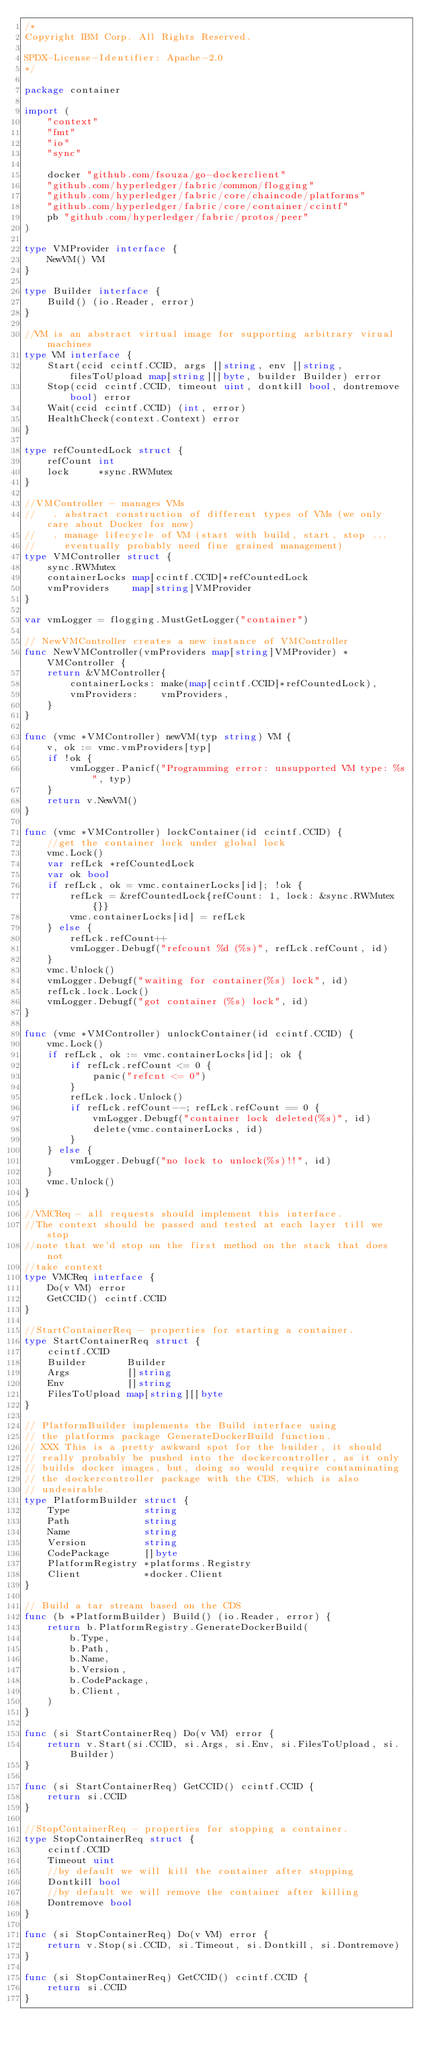Convert code to text. <code><loc_0><loc_0><loc_500><loc_500><_Go_>/*
Copyright IBM Corp. All Rights Reserved.

SPDX-License-Identifier: Apache-2.0
*/

package container

import (
	"context"
	"fmt"
	"io"
	"sync"

	docker "github.com/fsouza/go-dockerclient"
	"github.com/hyperledger/fabric/common/flogging"
	"github.com/hyperledger/fabric/core/chaincode/platforms"
	"github.com/hyperledger/fabric/core/container/ccintf"
	pb "github.com/hyperledger/fabric/protos/peer"
)

type VMProvider interface {
	NewVM() VM
}

type Builder interface {
	Build() (io.Reader, error)
}

//VM is an abstract virtual image for supporting arbitrary virual machines
type VM interface {
	Start(ccid ccintf.CCID, args []string, env []string, filesToUpload map[string][]byte, builder Builder) error
	Stop(ccid ccintf.CCID, timeout uint, dontkill bool, dontremove bool) error
	Wait(ccid ccintf.CCID) (int, error)
	HealthCheck(context.Context) error
}

type refCountedLock struct {
	refCount int
	lock     *sync.RWMutex
}

//VMController - manages VMs
//   . abstract construction of different types of VMs (we only care about Docker for now)
//   . manage lifecycle of VM (start with build, start, stop ...
//     eventually probably need fine grained management)
type VMController struct {
	sync.RWMutex
	containerLocks map[ccintf.CCID]*refCountedLock
	vmProviders    map[string]VMProvider
}

var vmLogger = flogging.MustGetLogger("container")

// NewVMController creates a new instance of VMController
func NewVMController(vmProviders map[string]VMProvider) *VMController {
	return &VMController{
		containerLocks: make(map[ccintf.CCID]*refCountedLock),
		vmProviders:    vmProviders,
	}
}

func (vmc *VMController) newVM(typ string) VM {
	v, ok := vmc.vmProviders[typ]
	if !ok {
		vmLogger.Panicf("Programming error: unsupported VM type: %s", typ)
	}
	return v.NewVM()
}

func (vmc *VMController) lockContainer(id ccintf.CCID) {
	//get the container lock under global lock
	vmc.Lock()
	var refLck *refCountedLock
	var ok bool
	if refLck, ok = vmc.containerLocks[id]; !ok {
		refLck = &refCountedLock{refCount: 1, lock: &sync.RWMutex{}}
		vmc.containerLocks[id] = refLck
	} else {
		refLck.refCount++
		vmLogger.Debugf("refcount %d (%s)", refLck.refCount, id)
	}
	vmc.Unlock()
	vmLogger.Debugf("waiting for container(%s) lock", id)
	refLck.lock.Lock()
	vmLogger.Debugf("got container (%s) lock", id)
}

func (vmc *VMController) unlockContainer(id ccintf.CCID) {
	vmc.Lock()
	if refLck, ok := vmc.containerLocks[id]; ok {
		if refLck.refCount <= 0 {
			panic("refcnt <= 0")
		}
		refLck.lock.Unlock()
		if refLck.refCount--; refLck.refCount == 0 {
			vmLogger.Debugf("container lock deleted(%s)", id)
			delete(vmc.containerLocks, id)
		}
	} else {
		vmLogger.Debugf("no lock to unlock(%s)!!", id)
	}
	vmc.Unlock()
}

//VMCReq - all requests should implement this interface.
//The context should be passed and tested at each layer till we stop
//note that we'd stop on the first method on the stack that does not
//take context
type VMCReq interface {
	Do(v VM) error
	GetCCID() ccintf.CCID
}

//StartContainerReq - properties for starting a container.
type StartContainerReq struct {
	ccintf.CCID
	Builder       Builder
	Args          []string
	Env           []string
	FilesToUpload map[string][]byte
}

// PlatformBuilder implements the Build interface using
// the platforms package GenerateDockerBuild function.
// XXX This is a pretty awkward spot for the builder, it should
// really probably be pushed into the dockercontroller, as it only
// builds docker images, but, doing so would require contaminating
// the dockercontroller package with the CDS, which is also
// undesirable.
type PlatformBuilder struct {
	Type             string
	Path             string
	Name             string
	Version          string
	CodePackage      []byte
	PlatformRegistry *platforms.Registry
	Client           *docker.Client
}

// Build a tar stream based on the CDS
func (b *PlatformBuilder) Build() (io.Reader, error) {
	return b.PlatformRegistry.GenerateDockerBuild(
		b.Type,
		b.Path,
		b.Name,
		b.Version,
		b.CodePackage,
		b.Client,
	)
}

func (si StartContainerReq) Do(v VM) error {
	return v.Start(si.CCID, si.Args, si.Env, si.FilesToUpload, si.Builder)
}

func (si StartContainerReq) GetCCID() ccintf.CCID {
	return si.CCID
}

//StopContainerReq - properties for stopping a container.
type StopContainerReq struct {
	ccintf.CCID
	Timeout uint
	//by default we will kill the container after stopping
	Dontkill bool
	//by default we will remove the container after killing
	Dontremove bool
}

func (si StopContainerReq) Do(v VM) error {
	return v.Stop(si.CCID, si.Timeout, si.Dontkill, si.Dontremove)
}

func (si StopContainerReq) GetCCID() ccintf.CCID {
	return si.CCID
}
</code> 